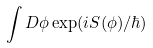<formula> <loc_0><loc_0><loc_500><loc_500>\int D \phi \exp ( i S ( \phi ) / \hbar { ) }</formula> 